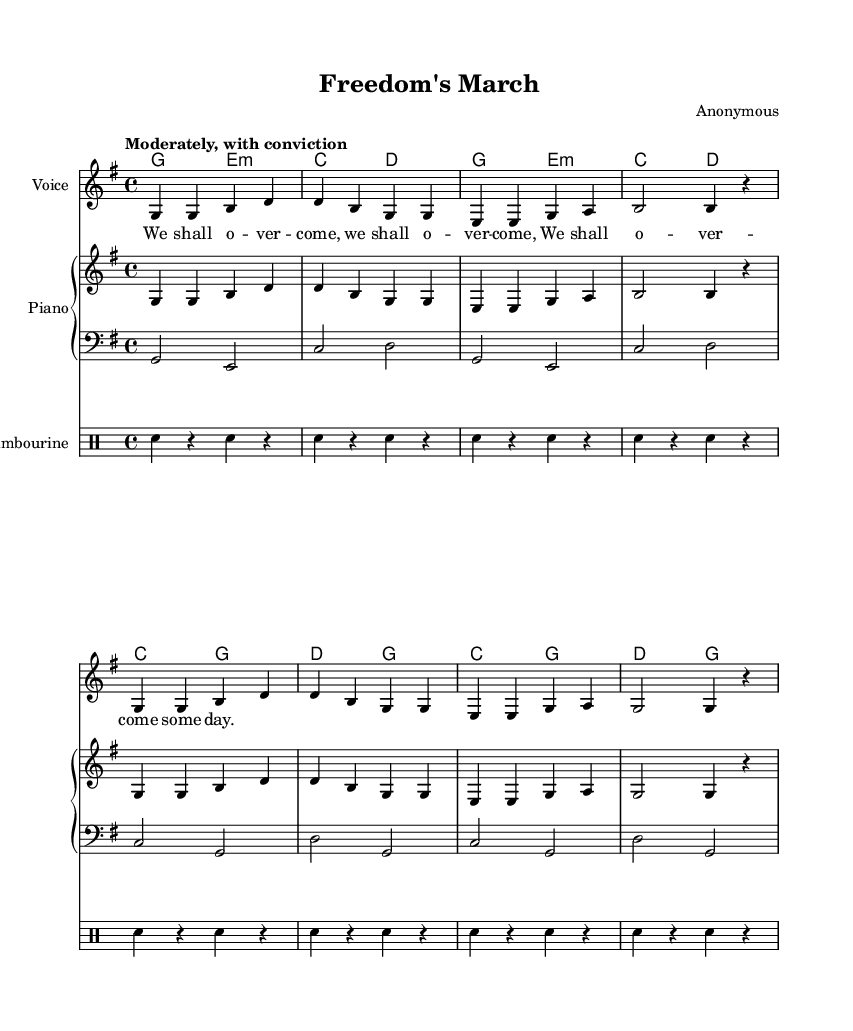What is the key signature of this music? The key signature is G major, which has one sharp (F#). This is indicated at the beginning of the staff.
Answer: G major What is the time signature of this music? The time signature is 4/4, written as a fraction at the beginning of the staff. This means there are four beats in each measure.
Answer: 4/4 What is the indicated tempo of this piece? The tempo marking states "Moderately, with conviction." This suggests a moderate speed and a strong sense of purpose in the performance.
Answer: Moderately, with conviction What is the total number of measures in the melody? By counting the measures shown in the melody section, there are eight measures. Each measured group is separated by a vertical bar.
Answer: Eight What is the primary lyrical theme of this spiritual? The lyrics focus on the phrase “We shall overcome,” which is a central message of hope and resilience commonly associated with the civil rights movement.
Answer: We shall overcome Which instrument is primarily playing the bass line? The bass line is indicated in the music with the clef labeled as "bass," showing that the lower staff is designated for a bass instrument.
Answer: Bass What type of rhythmic pattern is used in the tambourine part? The tambourine part features repeated strikes indicated by "sn" (snare), and rests, creating a rhythmic pattern that complements the melody.
Answer: Repeated strikes 